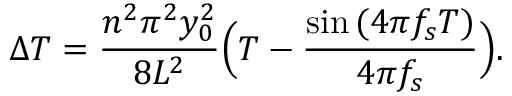<formula> <loc_0><loc_0><loc_500><loc_500>\Delta T = \frac { n ^ { 2 } \pi ^ { 2 } y _ { 0 } ^ { 2 } } { 8 L ^ { 2 } } \left ( T - \frac { \sin { ( 4 \pi f _ { s } T ) } } { 4 \pi f _ { s } } \right ) .</formula> 